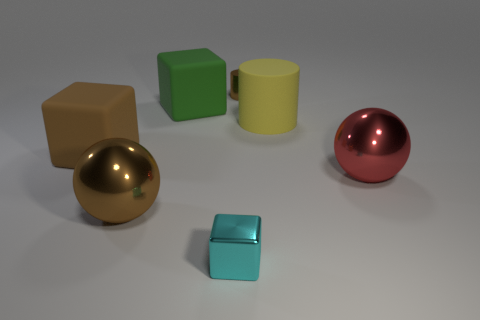What is the shape of the matte object right of the tiny shiny thing behind the brown matte block?
Make the answer very short. Cylinder. How many blue things are small shiny blocks or tiny shiny objects?
Give a very brief answer. 0. The small shiny cylinder has what color?
Provide a short and direct response. Brown. Is the yellow thing the same size as the brown cube?
Ensure brevity in your answer.  Yes. Are there any other things that are the same shape as the green matte object?
Keep it short and to the point. Yes. Do the small brown cylinder and the yellow thing that is right of the cyan shiny object have the same material?
Make the answer very short. No. Is the color of the rubber block left of the brown shiny ball the same as the tiny metallic cylinder?
Offer a terse response. Yes. How many brown things are on the left side of the tiny cylinder and behind the large red metallic thing?
Provide a succinct answer. 1. What number of other objects are the same material as the brown cube?
Keep it short and to the point. 2. Is the large sphere that is on the right side of the metallic cylinder made of the same material as the yellow object?
Keep it short and to the point. No. 